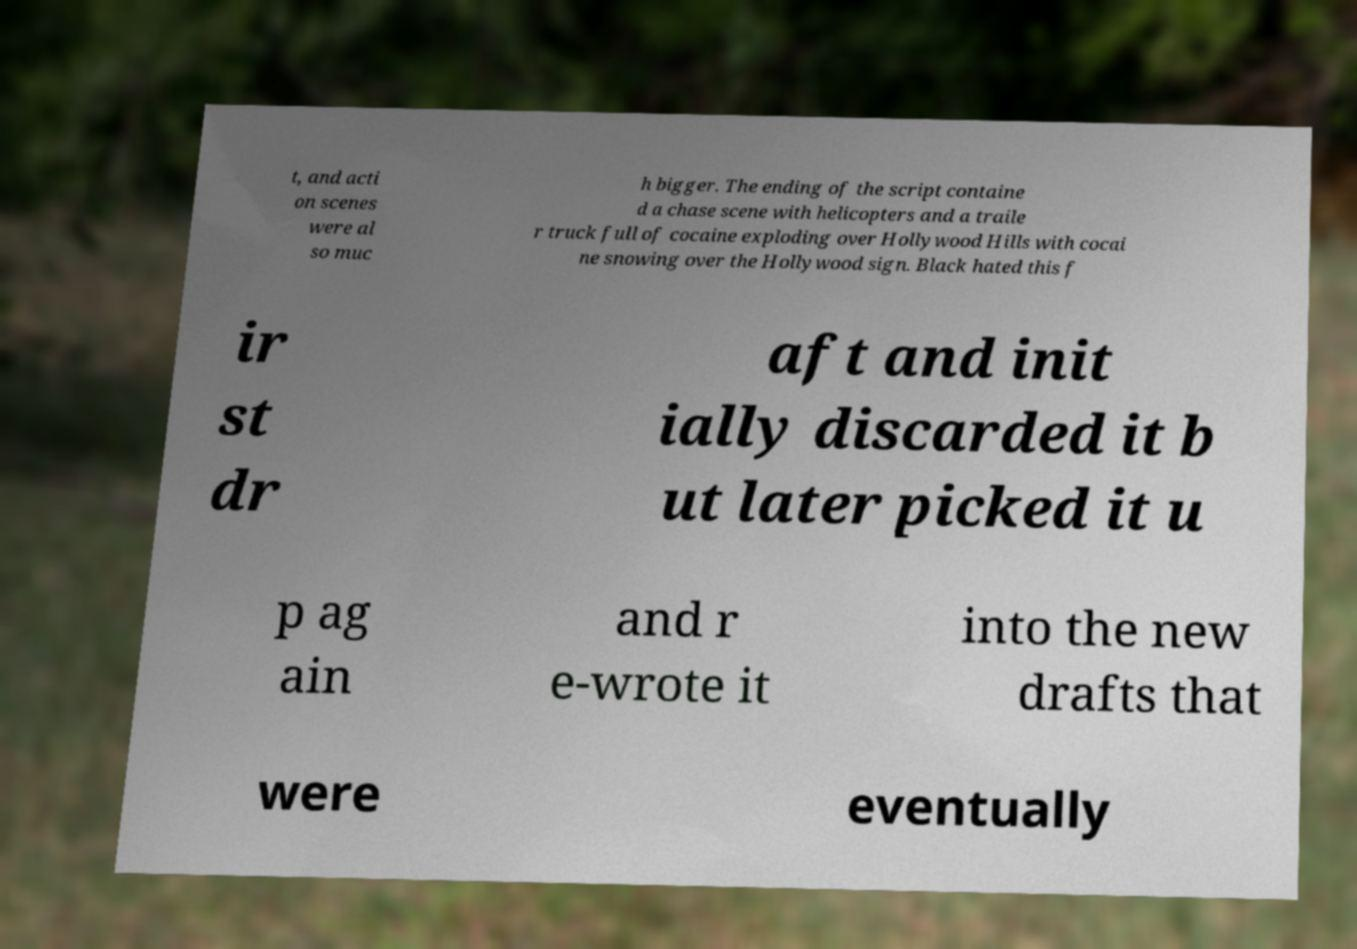There's text embedded in this image that I need extracted. Can you transcribe it verbatim? t, and acti on scenes were al so muc h bigger. The ending of the script containe d a chase scene with helicopters and a traile r truck full of cocaine exploding over Hollywood Hills with cocai ne snowing over the Hollywood sign. Black hated this f ir st dr aft and init ially discarded it b ut later picked it u p ag ain and r e-wrote it into the new drafts that were eventually 